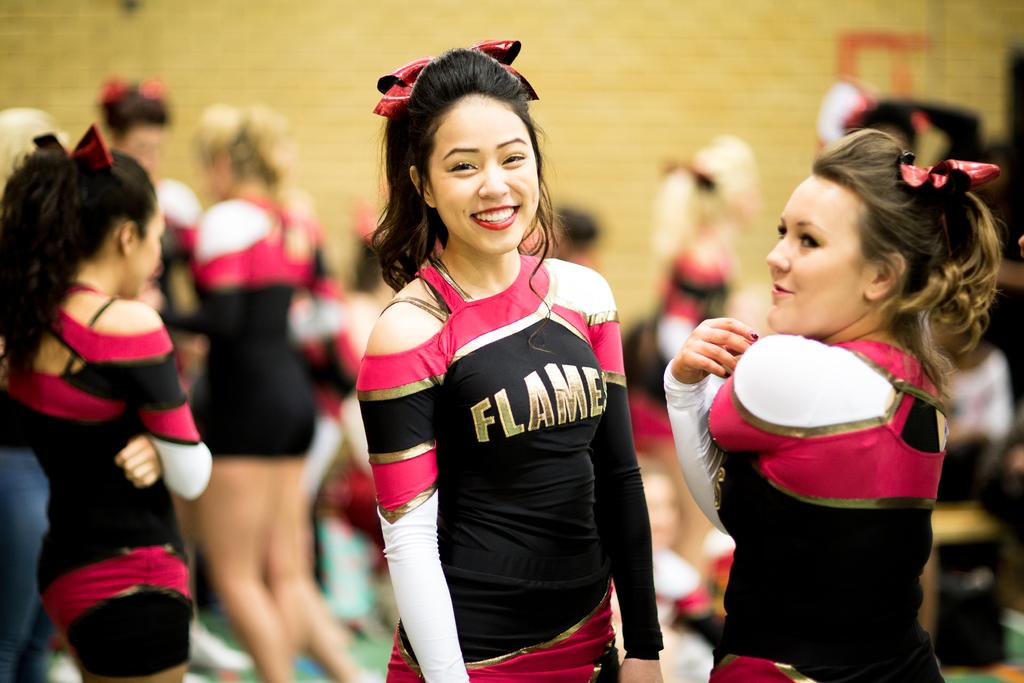What word is written on the ladies uniform?
Your answer should be compact. Flame. 